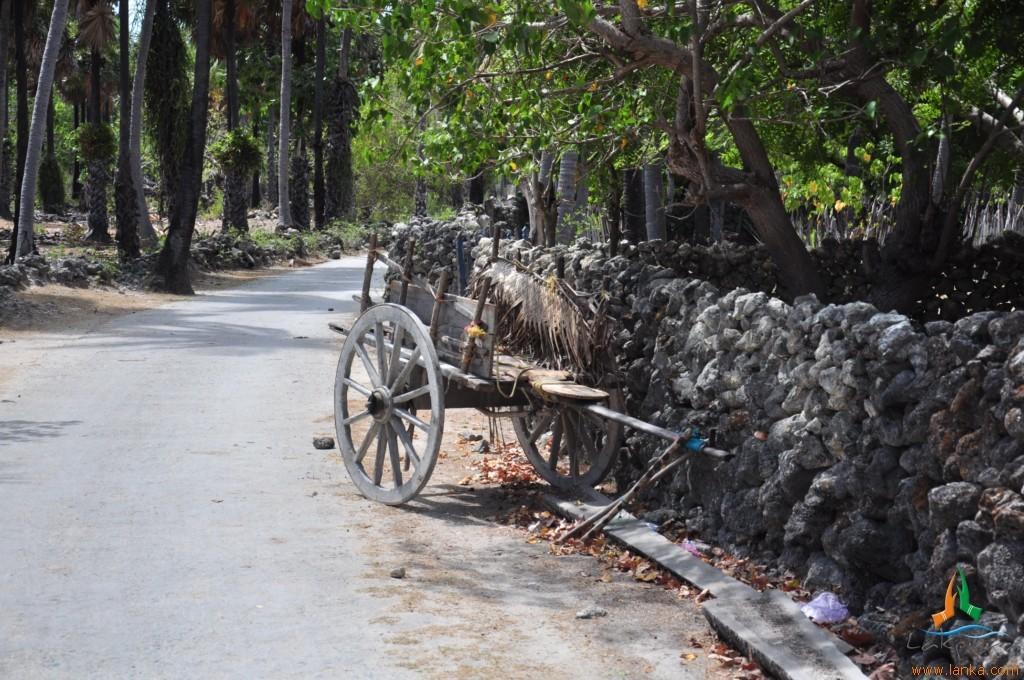Could you give a brief overview of what you see in this image? In this image we can see many trees. There is a wooden cart in the image. There is a road in the image. There is a wall in the image. 